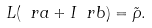<formula> <loc_0><loc_0><loc_500><loc_500>L ( \ r a + I \ r b ) = \tilde { \rho } .</formula> 